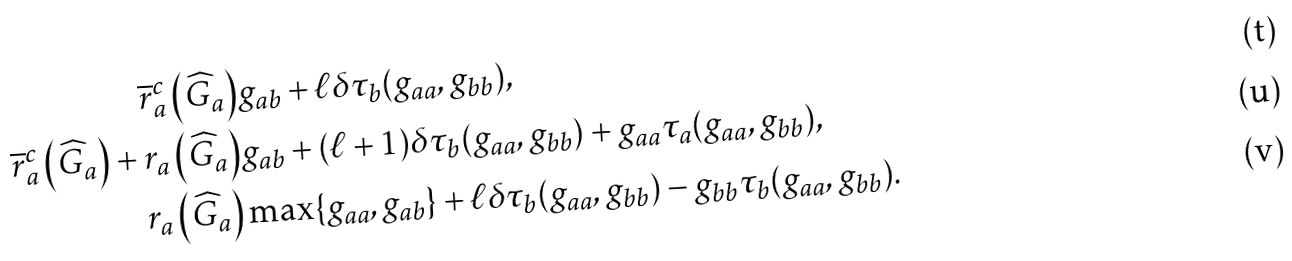<formula> <loc_0><loc_0><loc_500><loc_500>\overline { r } _ { a } ^ { c } \left ( \widehat { G } _ { a } \right ) & g _ { a b } + \ell \delta \tau _ { b } ( g _ { a a } , g _ { b b } ) , \\ \overline { r } _ { a } ^ { c } \left ( \widehat { G } _ { a } \right ) + r _ { a } \left ( \widehat { G } _ { a } \right ) & g _ { a b } + ( \ell + 1 ) \delta \tau _ { b } ( g _ { a a } , g _ { b b } ) + g _ { a a } \tau _ { a } ( g _ { a a } , g _ { b b } ) , \\ r _ { a } \left ( \widehat { G } _ { a } \right ) & \max \{ g _ { a a } , g _ { a b } \} + \ell \delta \tau _ { b } ( g _ { a a } , g _ { b b } ) - g _ { b b } \tau _ { b } ( g _ { a a } , g _ { b b } ) .</formula> 